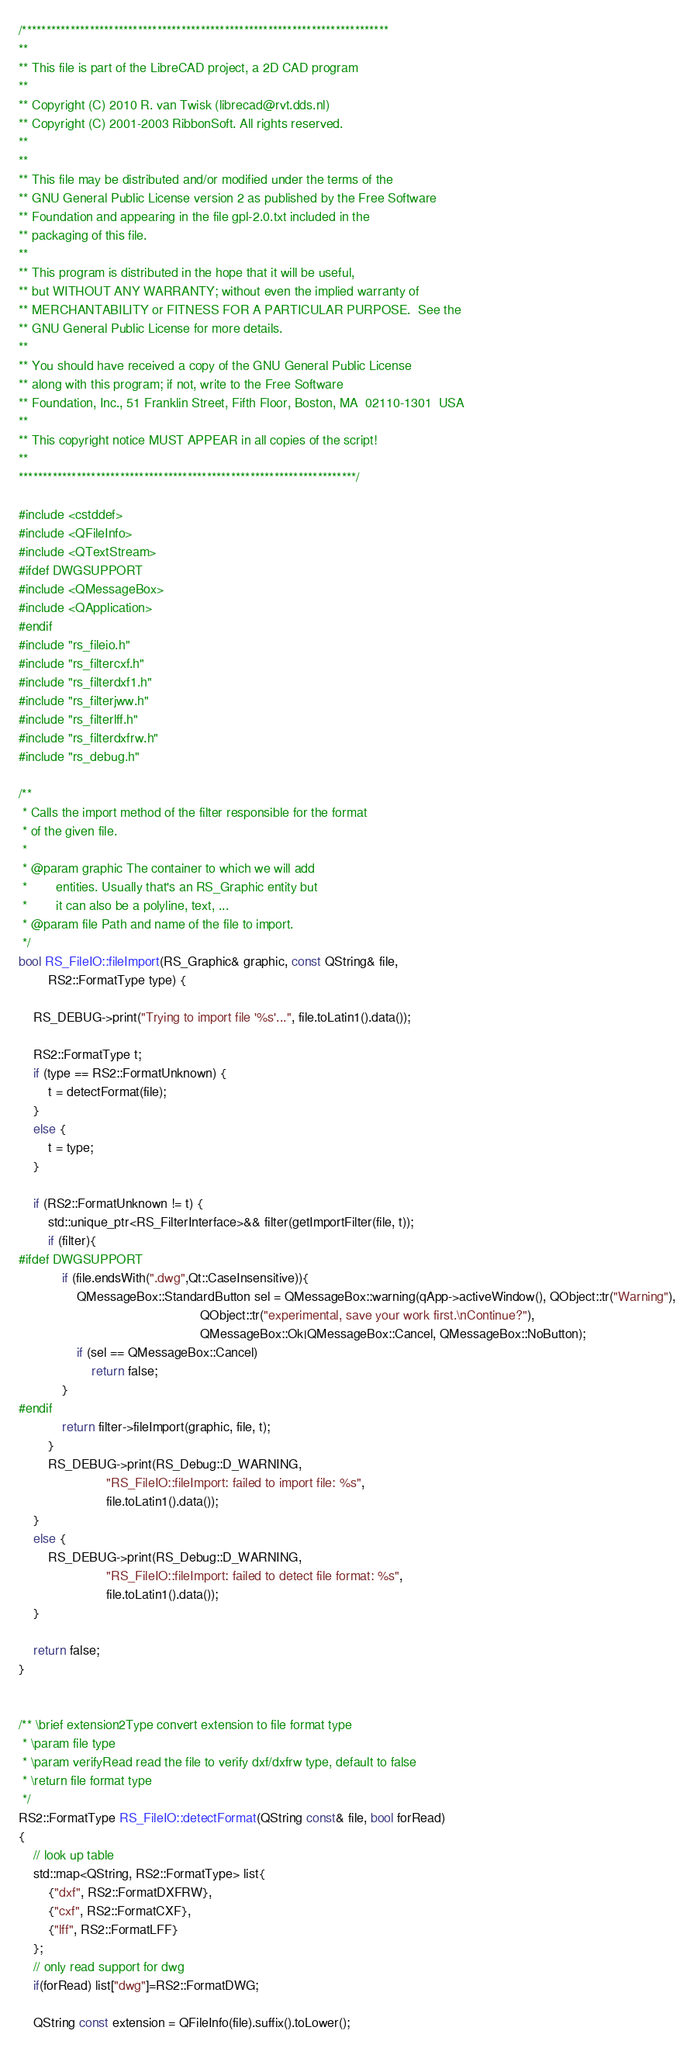Convert code to text. <code><loc_0><loc_0><loc_500><loc_500><_C++_>/****************************************************************************
**
** This file is part of the LibreCAD project, a 2D CAD program
**
** Copyright (C) 2010 R. van Twisk (librecad@rvt.dds.nl)
** Copyright (C) 2001-2003 RibbonSoft. All rights reserved.
**
**
** This file may be distributed and/or modified under the terms of the
** GNU General Public License version 2 as published by the Free Software
** Foundation and appearing in the file gpl-2.0.txt included in the
** packaging of this file.
**
** This program is distributed in the hope that it will be useful,
** but WITHOUT ANY WARRANTY; without even the implied warranty of
** MERCHANTABILITY or FITNESS FOR A PARTICULAR PURPOSE.  See the
** GNU General Public License for more details.
**
** You should have received a copy of the GNU General Public License
** along with this program; if not, write to the Free Software
** Foundation, Inc., 51 Franklin Street, Fifth Floor, Boston, MA  02110-1301  USA
**
** This copyright notice MUST APPEAR in all copies of the script!
**
**********************************************************************/

#include <cstddef>
#include <QFileInfo>
#include <QTextStream>
#ifdef DWGSUPPORT
#include <QMessageBox>
#include <QApplication>
#endif
#include "rs_fileio.h"
#include "rs_filtercxf.h"
#include "rs_filterdxf1.h"
#include "rs_filterjww.h"
#include "rs_filterlff.h"
#include "rs_filterdxfrw.h"
#include "rs_debug.h"

/**
 * Calls the import method of the filter responsible for the format
 * of the given file.
 *
 * @param graphic The container to which we will add
 *        entities. Usually that's an RS_Graphic entity but
 *        it can also be a polyline, text, ...
 * @param file Path and name of the file to import.
 */
bool RS_FileIO::fileImport(RS_Graphic& graphic, const QString& file,
        RS2::FormatType type) {

    RS_DEBUG->print("Trying to import file '%s'...", file.toLatin1().data());

    RS2::FormatType t;
    if (type == RS2::FormatUnknown) {
        t = detectFormat(file);
    }
    else {
        t = type;
    }

    if (RS2::FormatUnknown != t) {
		std::unique_ptr<RS_FilterInterface>&& filter(getImportFilter(file, t));
		if (filter){
#ifdef DWGSUPPORT
            if (file.endsWith(".dwg",Qt::CaseInsensitive)){
                QMessageBox::StandardButton sel = QMessageBox::warning(qApp->activeWindow(), QObject::tr("Warning"),
                                                  QObject::tr("experimental, save your work first.\nContinue?"),
                                                  QMessageBox::Ok|QMessageBox::Cancel, QMessageBox::NoButton);
                if (sel == QMessageBox::Cancel)
                    return false;
            }
#endif
            return filter->fileImport(graphic, file, t);
        }
        RS_DEBUG->print(RS_Debug::D_WARNING,
                        "RS_FileIO::fileImport: failed to import file: %s",
                        file.toLatin1().data());
    }
    else {
        RS_DEBUG->print(RS_Debug::D_WARNING,
                        "RS_FileIO::fileImport: failed to detect file format: %s",
                        file.toLatin1().data());
    }

    return false;
}


/** \brief extension2Type convert extension to file format type
 * \param file type
 * \param verifyRead read the file to verify dxf/dxfrw type, default to false
 * \return file format type
 */
RS2::FormatType RS_FileIO::detectFormat(QString const& file, bool forRead)
{
	// look up table
	std::map<QString, RS2::FormatType> list{
		{"dxf", RS2::FormatDXFRW},
		{"cxf", RS2::FormatCXF},
		{"lff", RS2::FormatLFF}
	};
	// only read support for dwg
	if(forRead) list["dwg"]=RS2::FormatDWG;

	QString const extension = QFileInfo(file).suffix().toLower();</code> 